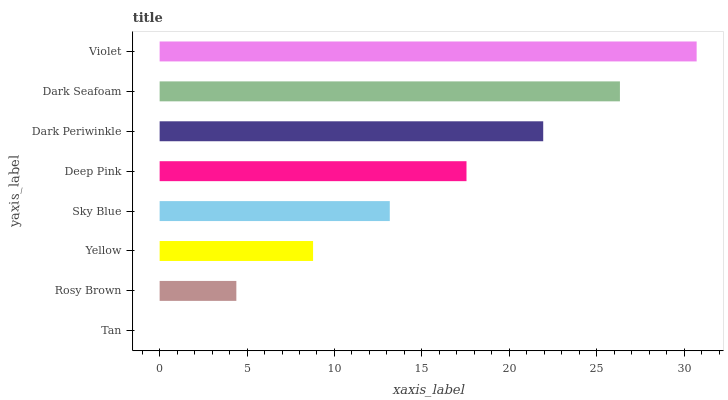Is Tan the minimum?
Answer yes or no. Yes. Is Violet the maximum?
Answer yes or no. Yes. Is Rosy Brown the minimum?
Answer yes or no. No. Is Rosy Brown the maximum?
Answer yes or no. No. Is Rosy Brown greater than Tan?
Answer yes or no. Yes. Is Tan less than Rosy Brown?
Answer yes or no. Yes. Is Tan greater than Rosy Brown?
Answer yes or no. No. Is Rosy Brown less than Tan?
Answer yes or no. No. Is Deep Pink the high median?
Answer yes or no. Yes. Is Sky Blue the low median?
Answer yes or no. Yes. Is Rosy Brown the high median?
Answer yes or no. No. Is Rosy Brown the low median?
Answer yes or no. No. 